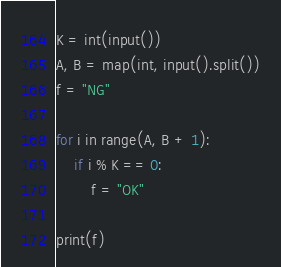<code> <loc_0><loc_0><loc_500><loc_500><_Python_>K = int(input())
A, B = map(int, input().split())
f = "NG"

for i in range(A, B + 1):
    if i % K == 0:
        f = "OK"

print(f)</code> 